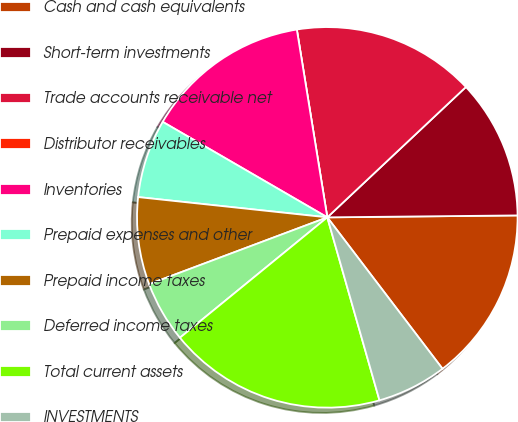Convert chart. <chart><loc_0><loc_0><loc_500><loc_500><pie_chart><fcel>Cash and cash equivalents<fcel>Short-term investments<fcel>Trade accounts receivable net<fcel>Distributor receivables<fcel>Inventories<fcel>Prepaid expenses and other<fcel>Prepaid income taxes<fcel>Deferred income taxes<fcel>Total current assets<fcel>INVESTMENTS<nl><fcel>14.81%<fcel>11.85%<fcel>15.55%<fcel>0.0%<fcel>14.07%<fcel>6.67%<fcel>7.41%<fcel>5.19%<fcel>18.52%<fcel>5.93%<nl></chart> 